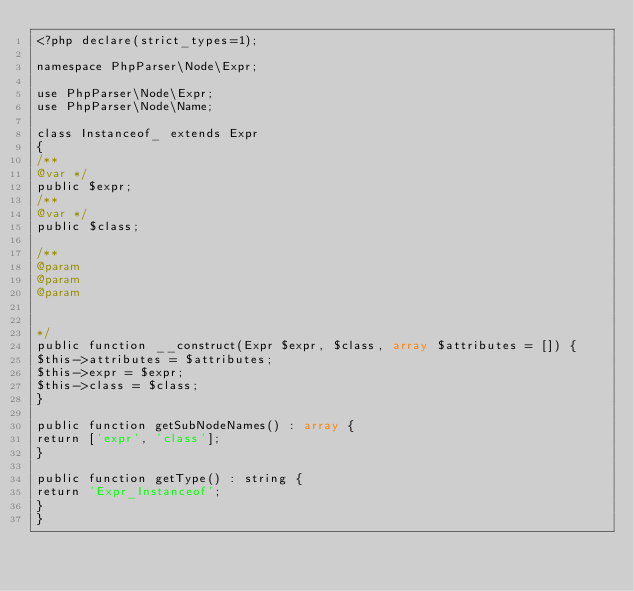Convert code to text. <code><loc_0><loc_0><loc_500><loc_500><_PHP_><?php declare(strict_types=1);

namespace PhpParser\Node\Expr;

use PhpParser\Node\Expr;
use PhpParser\Node\Name;

class Instanceof_ extends Expr
{
/**
@var */
public $expr;
/**
@var */
public $class;

/**
@param
@param
@param


*/
public function __construct(Expr $expr, $class, array $attributes = []) {
$this->attributes = $attributes;
$this->expr = $expr;
$this->class = $class;
}

public function getSubNodeNames() : array {
return ['expr', 'class'];
}

public function getType() : string {
return 'Expr_Instanceof';
}
}
</code> 